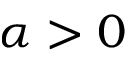<formula> <loc_0><loc_0><loc_500><loc_500>\alpha > 0</formula> 